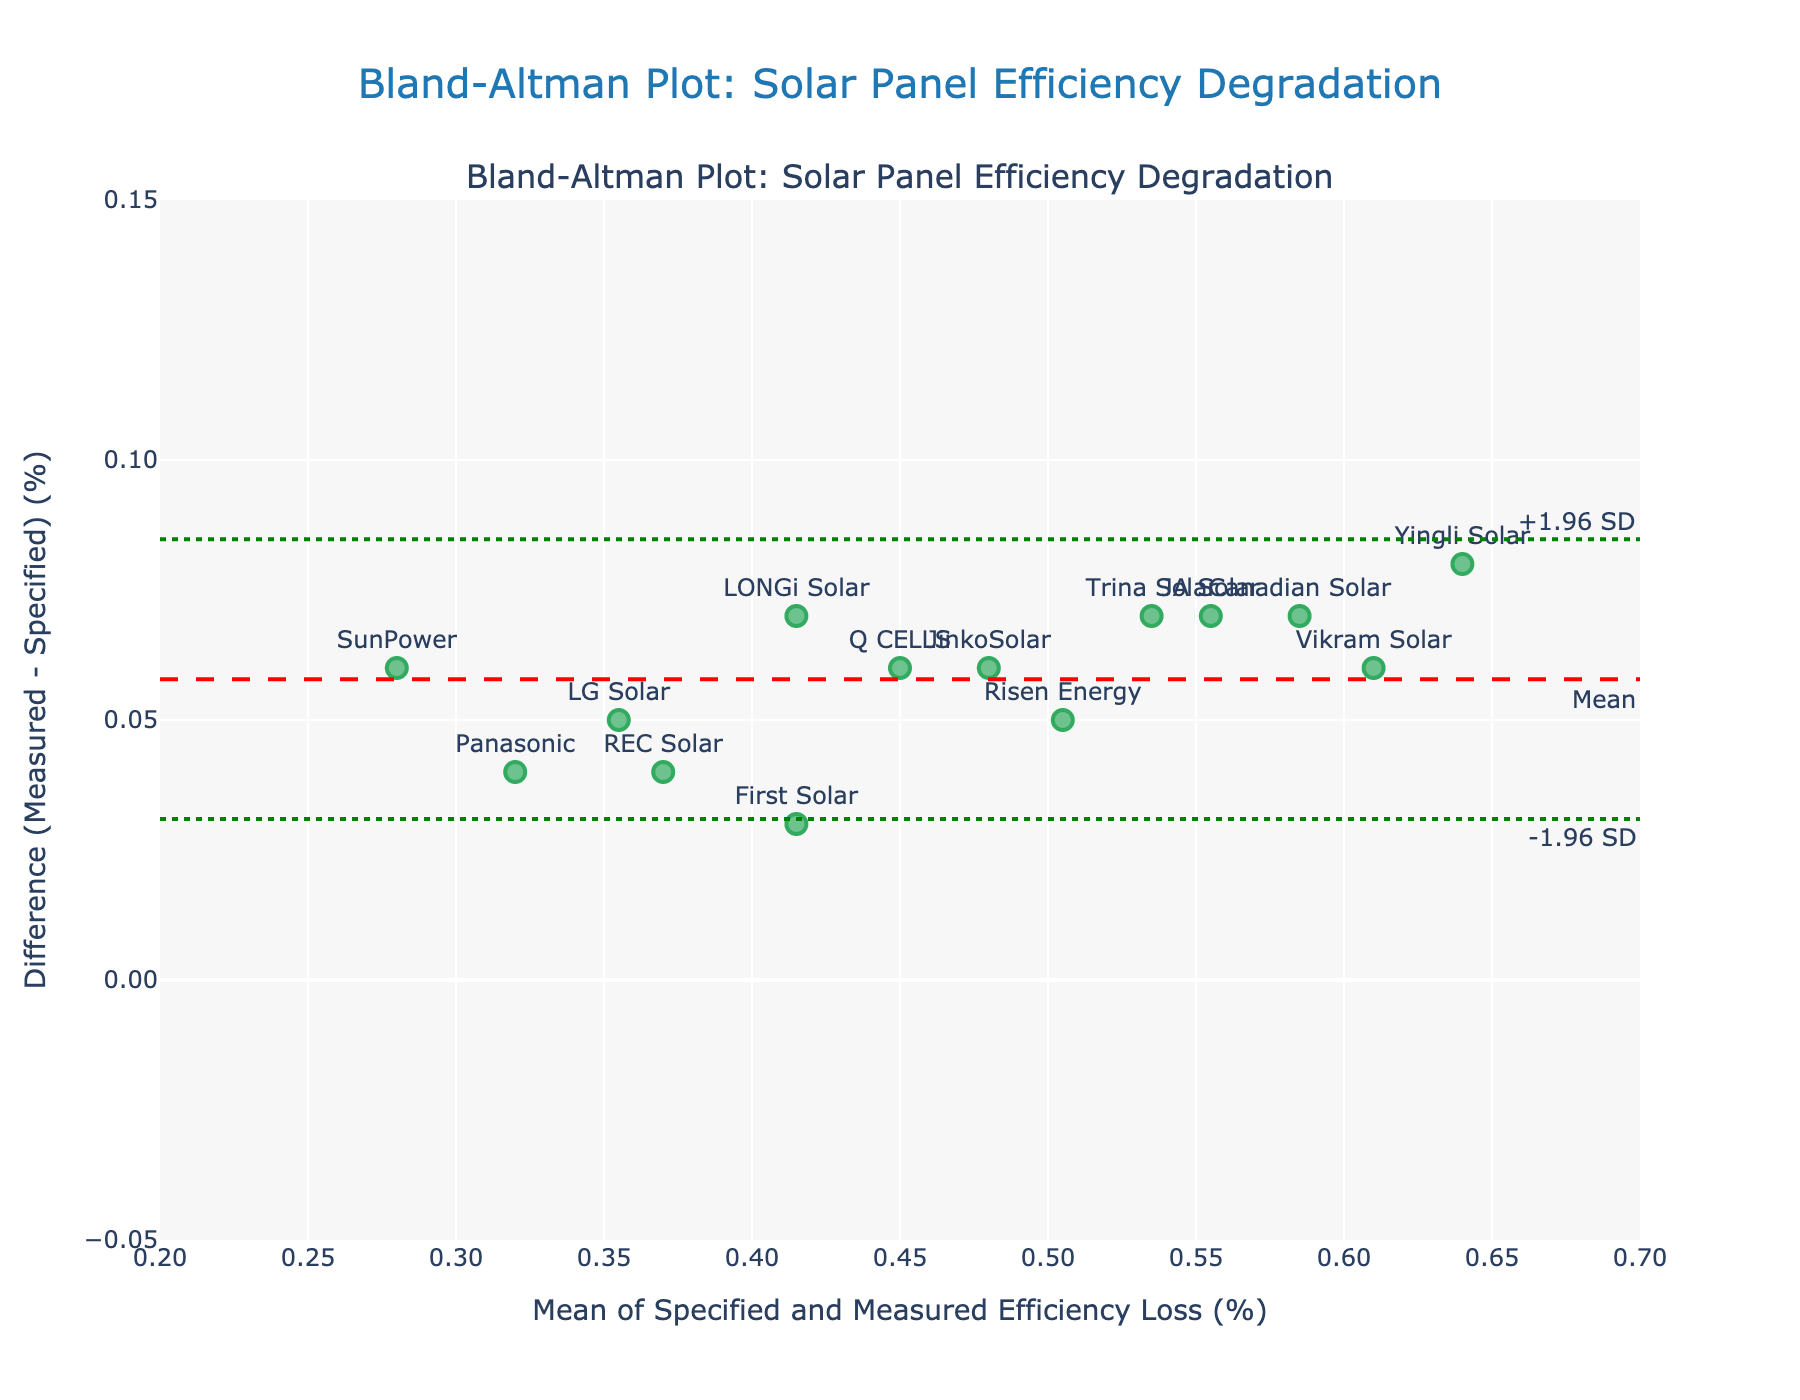What is the title of the plot? The title of the plot is located at the top center of the figure. It is written in a larger font compared to the other text elements.
Answer: Bland-Altman Plot: Solar Panel Efficiency Degradation What does the y-axis represent? The label of the y-axis is located on the left side of the plot. It specifies what the vertical axis measures.
Answer: Difference (Measured - Specified) (%) How many solar panel manufacturers' data points are there in the plot? Each marker on the plot represents a data point corresponding to a solar panel manufacturer. Count the number of markers.
Answer: 14 Which solar panel manufacturer has the largest positive difference between measured and specified efficiency loss? Look for the marker that has the highest vertical position (y-value) among the data points and identify the corresponding label.
Answer: Yingli Solar What is the mean difference between measured and specified efficiency loss? The mean difference is represented by the horizontal dashed red line in the plot. Its value is annotated on the right end of the line.
Answer: 0.06% What are the upper and lower limits of agreement in the plot? The upper and lower limits of agreement are represented by the green dotted lines. The values are annotated at the right ends of these lines.
Answer: +1.96 SD: 0.112, -1.96 SD: 0.008 Which manufacturers have a measured efficiency loss higher than the specified efficiency loss? Identify the data points that are above the horizontal line where the y-value is zero and list their labels.
Answer: SunPower, LG Solar, Canadian Solar, JinkoSolar, Trina Solar, REC Solar, Panasonic, Q CELLS, LONGi Solar, Risen Energy, JA Solar, Vikram Solar, Yingli Solar Which manufacturer has the smallest mean efficiency loss? Look for the data point with the smallest x-value (horizontal position) and identify the corresponding label.
Answer: SunPower What is the approximate difference in efficiency loss for LG Solar? Locate the data point labeled "LG Solar" and determine its vertical position (y-value).
Answer: Approximately 0.05% Are there any data points outside the limits of agreement? Check if there are any markers outside the range specified by the green dotted lines representing the limits of agreement.
Answer: No 